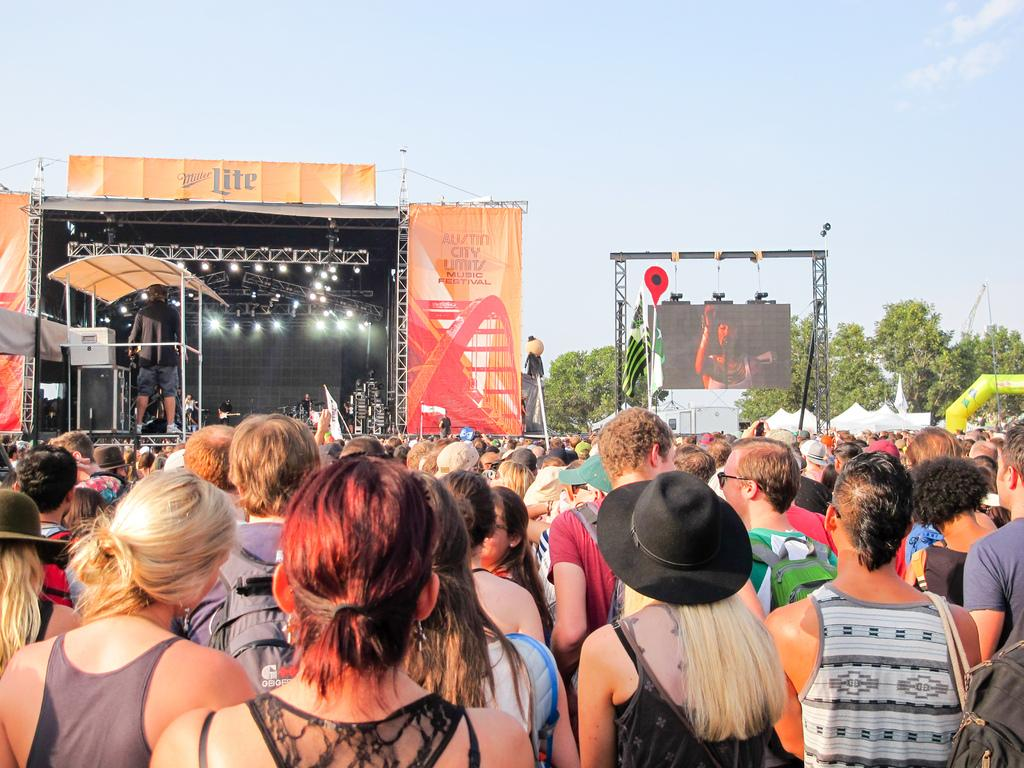What are the people in the image doing? The people in the image are standing on the land. What structure can be seen on the left side of the image? There is a stage on the left side of the image. What type of natural environment is visible in the background of the image? There are trees in the background of the image. What is visible in the sky in the background of the image? The sky is visible in the background of the image. What type of curve can be seen in the image? There is no curve present in the image. What is the taste of the vest in the image? There is no vest present in the image, and therefore no taste can be associated with it. 